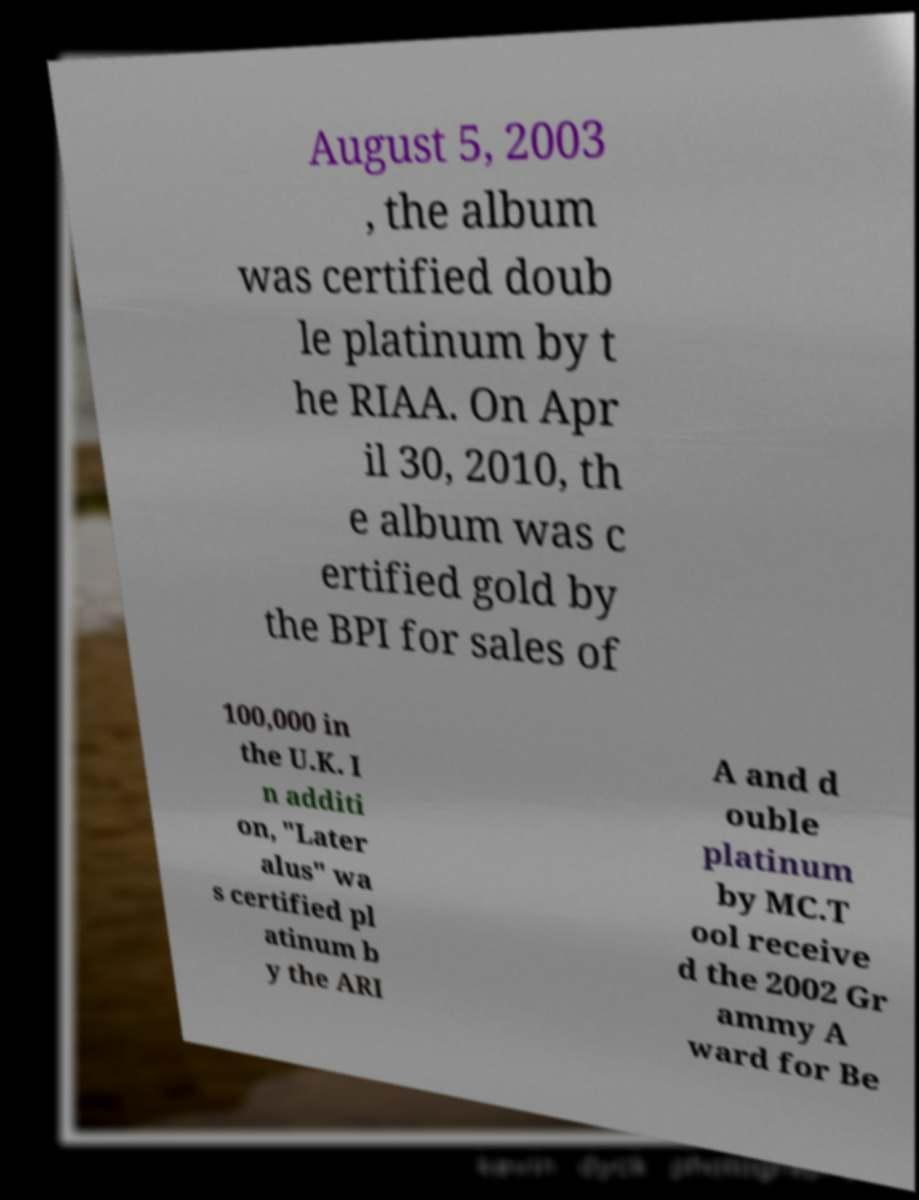Please read and relay the text visible in this image. What does it say? August 5, 2003 , the album was certified doub le platinum by t he RIAA. On Apr il 30, 2010, th e album was c ertified gold by the BPI for sales of 100,000 in the U.K. I n additi on, "Later alus" wa s certified pl atinum b y the ARI A and d ouble platinum by MC.T ool receive d the 2002 Gr ammy A ward for Be 